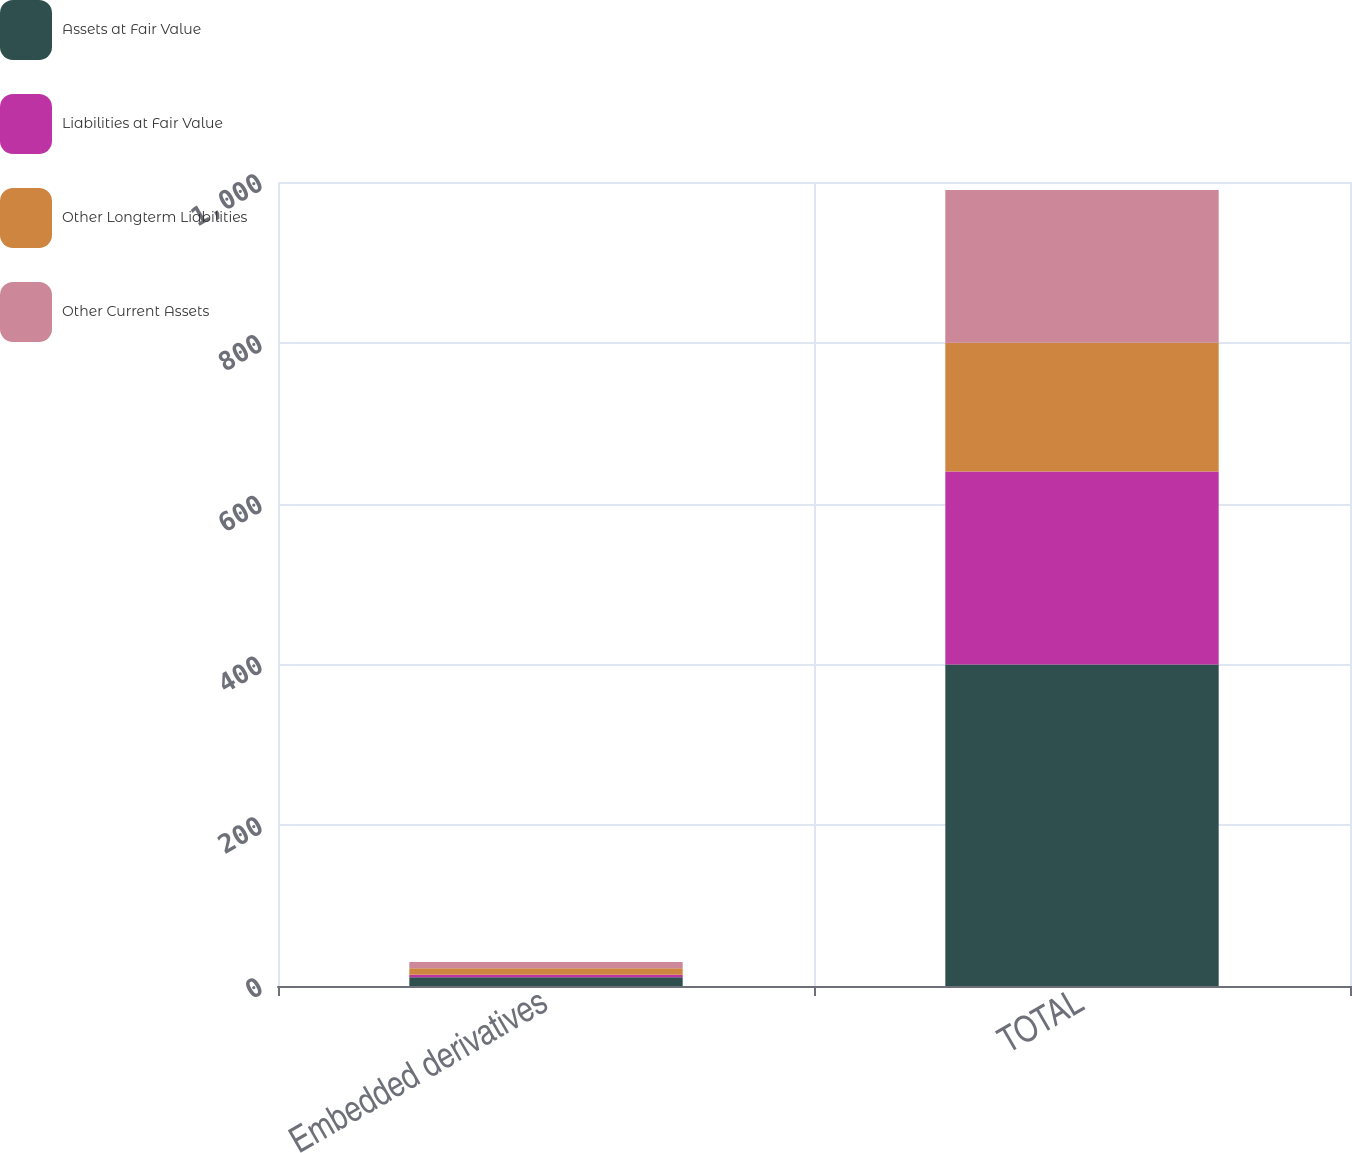Convert chart to OTSL. <chart><loc_0><loc_0><loc_500><loc_500><stacked_bar_chart><ecel><fcel>Embedded derivatives<fcel>TOTAL<nl><fcel>Assets at Fair Value<fcel>11<fcel>400<nl><fcel>Liabilities at Fair Value<fcel>3<fcel>240<nl><fcel>Other Longterm Liabilities<fcel>8<fcel>160<nl><fcel>Other Current Assets<fcel>8<fcel>190<nl></chart> 